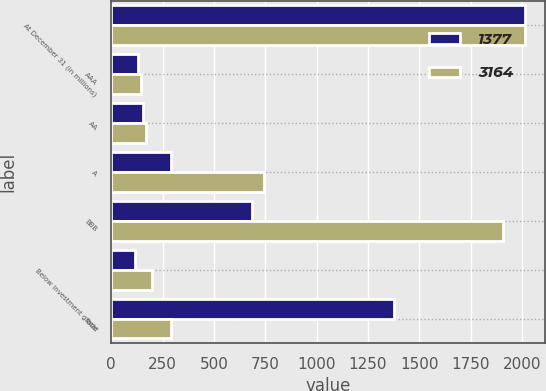Convert chart to OTSL. <chart><loc_0><loc_0><loc_500><loc_500><stacked_bar_chart><ecel><fcel>At December 31 (in millions)<fcel>AAA<fcel>AA<fcel>A<fcel>BBB<fcel>Below investment grade<fcel>Total<nl><fcel>1377<fcel>2013<fcel>129<fcel>156<fcel>291<fcel>687<fcel>114<fcel>1377<nl><fcel>3164<fcel>2012<fcel>145<fcel>168<fcel>745<fcel>1907<fcel>199<fcel>291<nl></chart> 